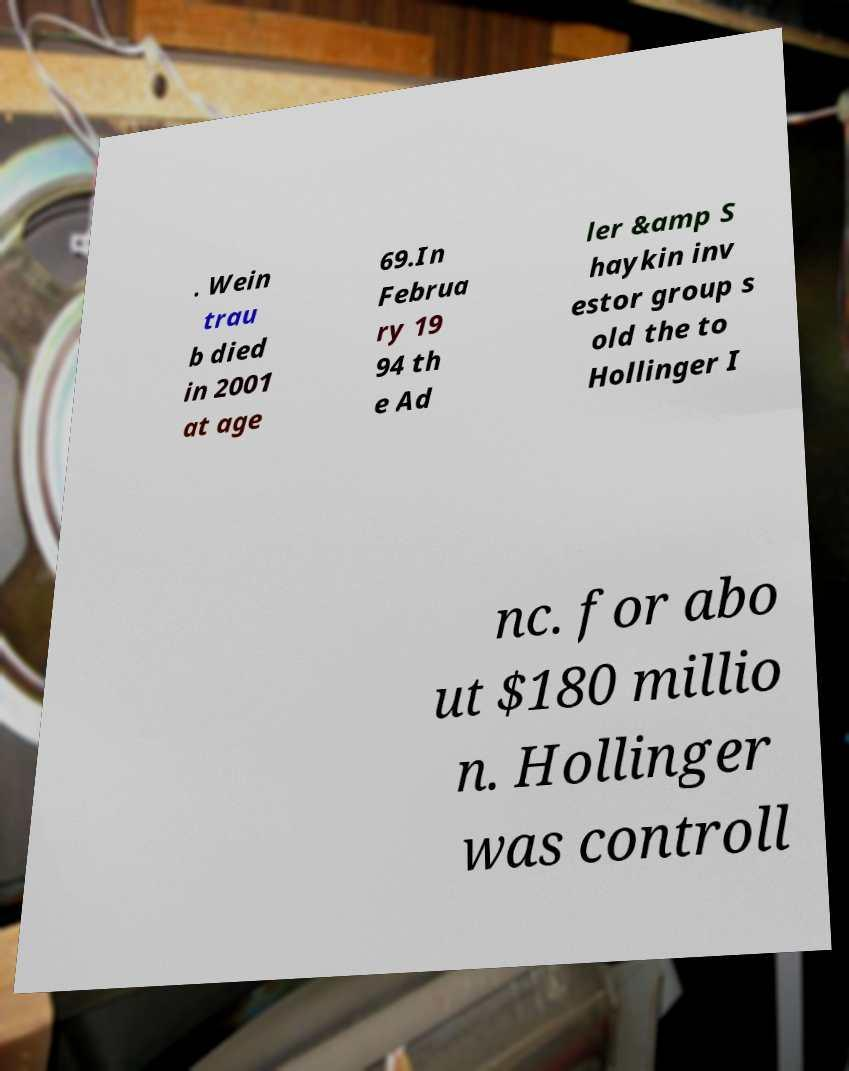Please read and relay the text visible in this image. What does it say? . Wein trau b died in 2001 at age 69.In Februa ry 19 94 th e Ad ler &amp S haykin inv estor group s old the to Hollinger I nc. for abo ut $180 millio n. Hollinger was controll 